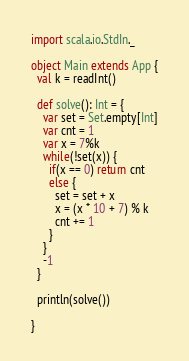Convert code to text. <code><loc_0><loc_0><loc_500><loc_500><_Scala_>import scala.io.StdIn._

object Main extends App {
  val k = readInt()

  def solve(): Int = {
    var set = Set.empty[Int]
    var cnt = 1
    var x = 7%k
    while(!set(x)) {
      if(x == 0) return cnt
      else {
        set = set + x
        x = (x * 10 + 7) % k
        cnt += 1
      }
    }
    -1
  }

  println(solve())

}

</code> 